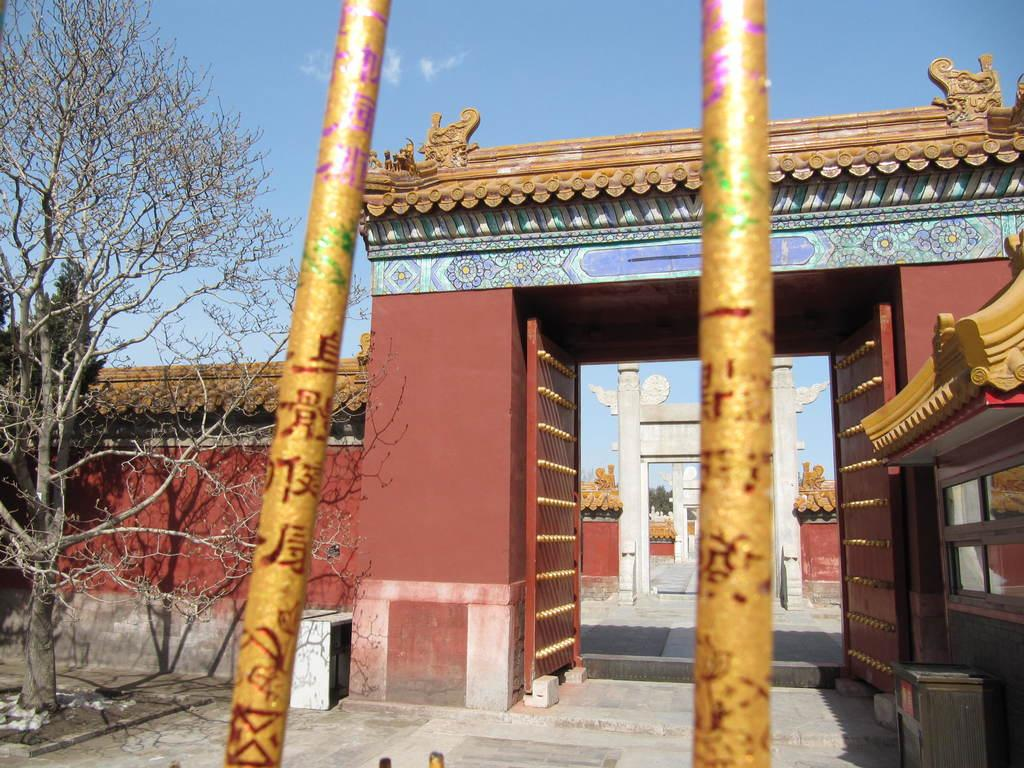What type of structure is visible in the image? There is a compound wall in the image. What feature is present on the compound wall? The compound wall has an entrance arch. What can be seen outside the compound wall? There is a tree outside the compound wall. What type of fog can be seen surrounding the compound wall in the image? There is no fog present in the image; it is a clear day. What shape is the playground outside the compound wall in the image? There is no playground present in the image. 